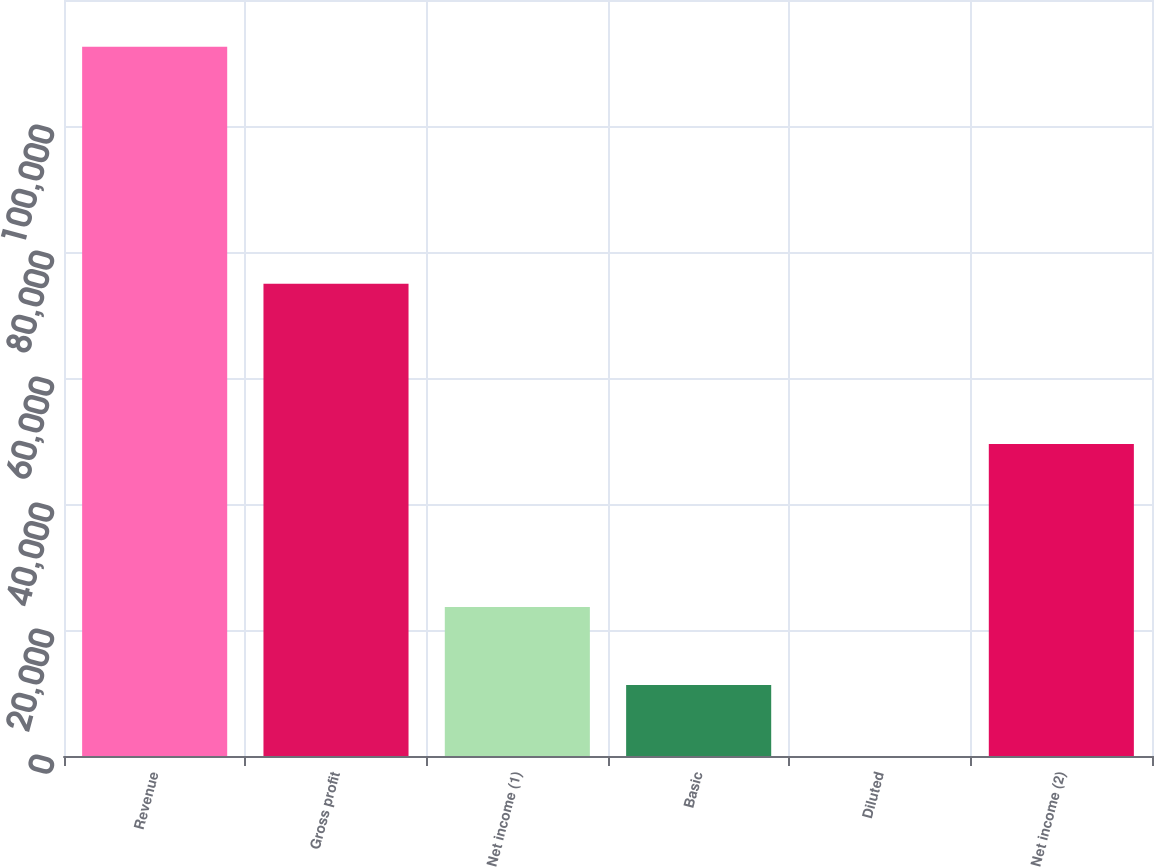<chart> <loc_0><loc_0><loc_500><loc_500><bar_chart><fcel>Revenue<fcel>Gross profit<fcel>Net income (1)<fcel>Basic<fcel>Diluted<fcel>Net income (2)<nl><fcel>112567<fcel>74945<fcel>23641<fcel>11257.3<fcel>0.62<fcel>49525<nl></chart> 